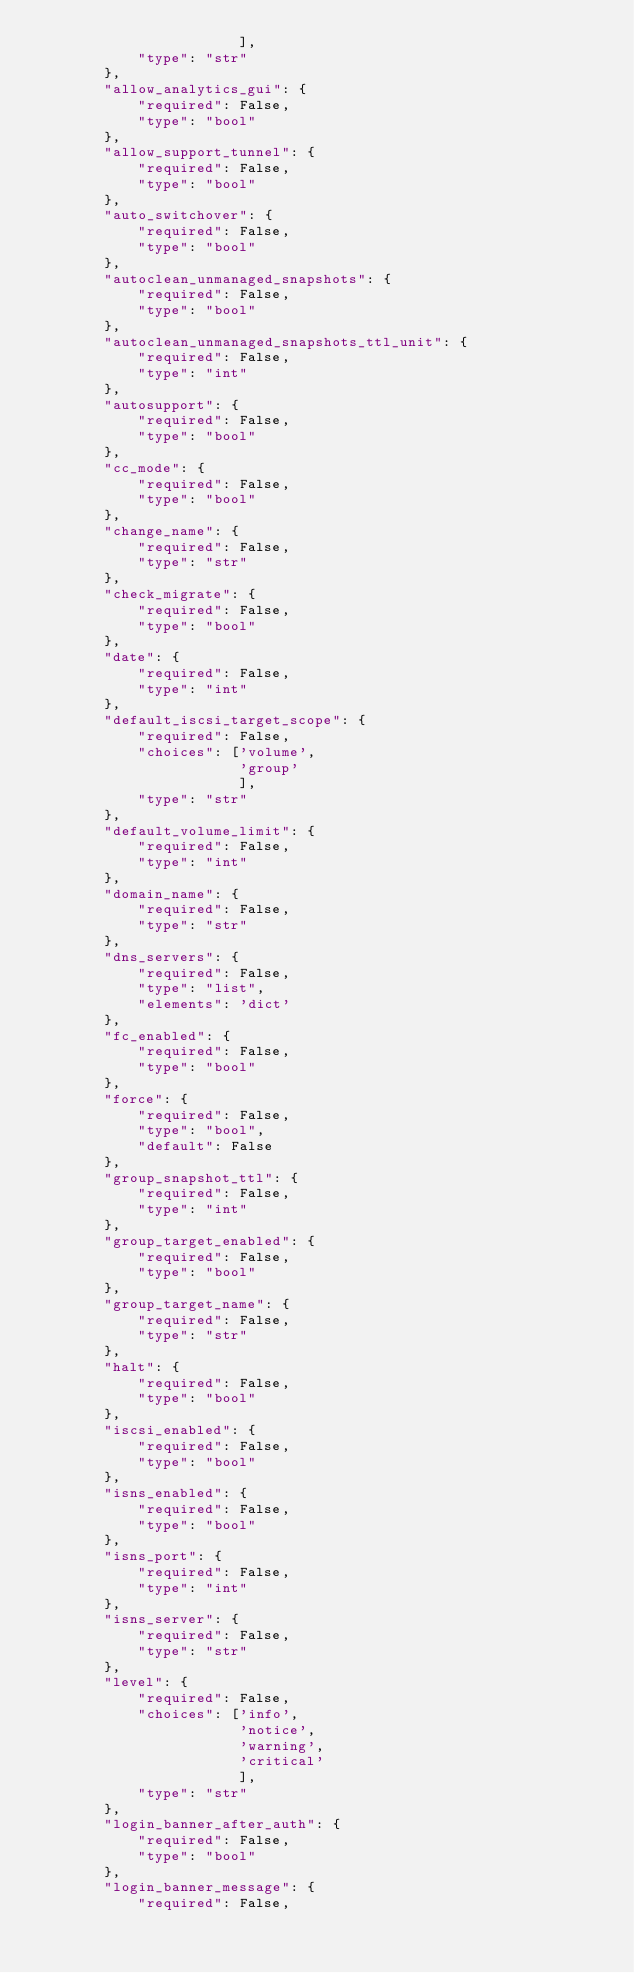<code> <loc_0><loc_0><loc_500><loc_500><_Python_>                        ],
            "type": "str"
        },
        "allow_analytics_gui": {
            "required": False,
            "type": "bool"
        },
        "allow_support_tunnel": {
            "required": False,
            "type": "bool"
        },
        "auto_switchover": {
            "required": False,
            "type": "bool"
        },
        "autoclean_unmanaged_snapshots": {
            "required": False,
            "type": "bool"
        },
        "autoclean_unmanaged_snapshots_ttl_unit": {
            "required": False,
            "type": "int"
        },
        "autosupport": {
            "required": False,
            "type": "bool"
        },
        "cc_mode": {
            "required": False,
            "type": "bool"
        },
        "change_name": {
            "required": False,
            "type": "str"
        },
        "check_migrate": {
            "required": False,
            "type": "bool"
        },
        "date": {
            "required": False,
            "type": "int"
        },
        "default_iscsi_target_scope": {
            "required": False,
            "choices": ['volume',
                        'group'
                        ],
            "type": "str"
        },
        "default_volume_limit": {
            "required": False,
            "type": "int"
        },
        "domain_name": {
            "required": False,
            "type": "str"
        },
        "dns_servers": {
            "required": False,
            "type": "list",
            "elements": 'dict'
        },
        "fc_enabled": {
            "required": False,
            "type": "bool"
        },
        "force": {
            "required": False,
            "type": "bool",
            "default": False
        },
        "group_snapshot_ttl": {
            "required": False,
            "type": "int"
        },
        "group_target_enabled": {
            "required": False,
            "type": "bool"
        },
        "group_target_name": {
            "required": False,
            "type": "str"
        },
        "halt": {
            "required": False,
            "type": "bool"
        },
        "iscsi_enabled": {
            "required": False,
            "type": "bool"
        },
        "isns_enabled": {
            "required": False,
            "type": "bool"
        },
        "isns_port": {
            "required": False,
            "type": "int"
        },
        "isns_server": {
            "required": False,
            "type": "str"
        },
        "level": {
            "required": False,
            "choices": ['info',
                        'notice',
                        'warning',
                        'critical'
                        ],
            "type": "str"
        },
        "login_banner_after_auth": {
            "required": False,
            "type": "bool"
        },
        "login_banner_message": {
            "required": False,</code> 